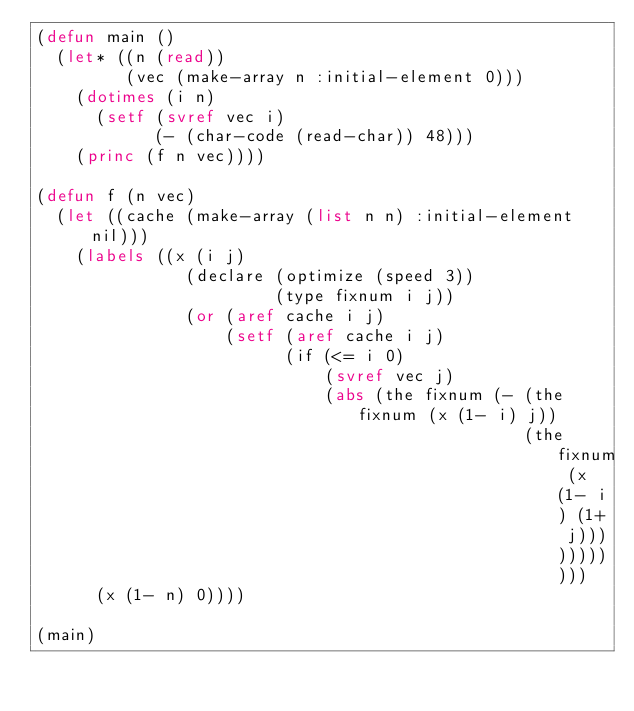Convert code to text. <code><loc_0><loc_0><loc_500><loc_500><_Lisp_>(defun main ()
  (let* ((n (read))
         (vec (make-array n :initial-element 0)))
    (dotimes (i n)
      (setf (svref vec i)
            (- (char-code (read-char)) 48)))
    (princ (f n vec))))

(defun f (n vec)
  (let ((cache (make-array (list n n) :initial-element nil)))
    (labels ((x (i j)
               (declare (optimize (speed 3))
                        (type fixnum i j))
               (or (aref cache i j)
                   (setf (aref cache i j)
                         (if (<= i 0)
                             (svref vec j)
                             (abs (the fixnum (- (the fixnum (x (1- i) j))
                                                 (the fixnum (x (1- i) (1+ j)))))))))))
      (x (1- n) 0))))

(main)
</code> 